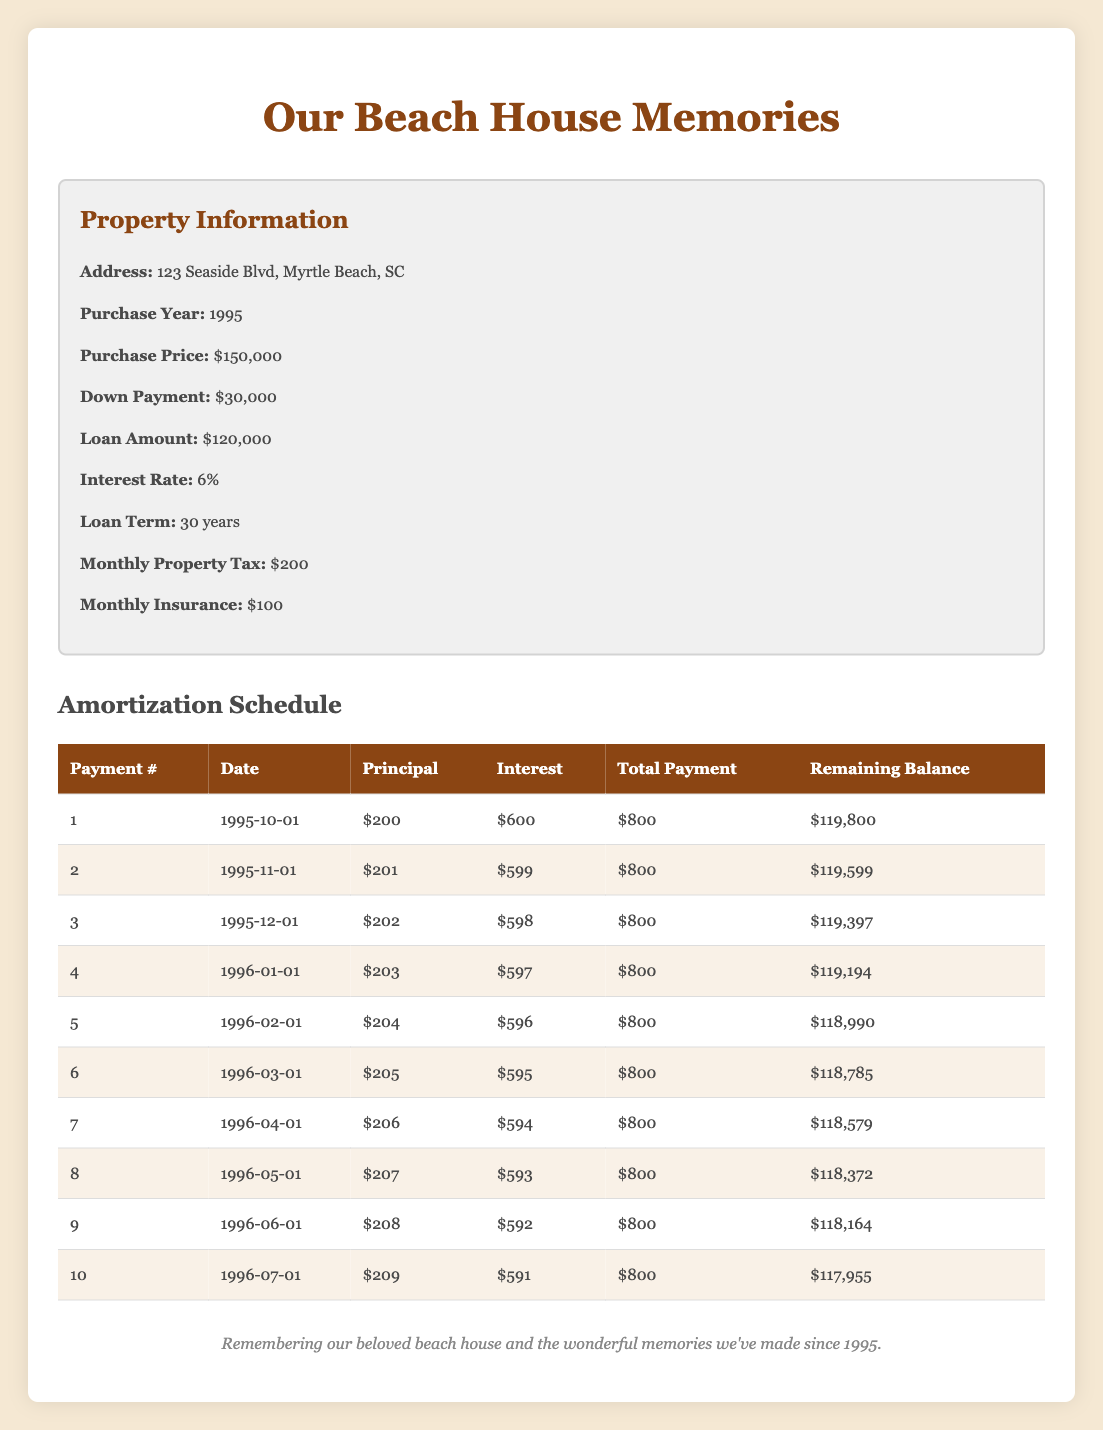What is the total monthly payment for the vacation home? The total payment for each month is listed in the "Total Payment" column. All entries show a total payment of 800, therefore for each month, it remains the same.
Answer: 800 How much is the principal payment in the 5th month? The principal payment for each month is found in the "Principal" column. For the 5th month, it is listed as 204.
Answer: 204 What is the interest payment in the 2nd month? The interest payment for the 2nd month is specified in the "Interest" column. It shows an amount of 599.
Answer: 599 Is the total payment constant throughout the payments? By examining the "Total Payment" column, all entries show 800. Therefore, yes, the total payment remains constant.
Answer: Yes What is the remaining balance after the 10th payment? The remaining balance after the 10th payment can be found in the last row of the "Remaining Balance" column. It shows a balance of 117,955.
Answer: 117,955 How much total principal is paid off after the first 10 months? To find the total principal paid, sum the "Principal" amounts for the first 10 months: 200 + 201 + 202 + 203 + 204 + 205 + 206 + 207 + 208 + 209 = 2,055.
Answer: 2,055 Which month has the highest interest payment, and what is that amount? By reviewing the "Interest" column, the interest payments fluctuate but decrease monthly. The highest amount, found in the first row, is 600. Hence, the first month has the highest interest payment.
Answer: 600, first month What is the total interest paid from the 6th to the 10th payment? To find the total interest from these payments, sum the interest payments for those months: 595 + 594 + 593 + 592 + 591 = 2965.
Answer: 2965 Is the principal payment increasing or decreasing over the first 10 payments? By analyzing the "Principal" column, the values of 200, 201, 202, ..., 209 demonstrate an increasing trend each month.
Answer: Increasing What is the average principal payment over the first 10 months? The principal payments for the first 10 months are 200, 201, 202, 203, 204, 205, 206, 207, 208, and 209. Their sum is 2,055. Divide this by 10 gives an average of 205.5.
Answer: 205.5 